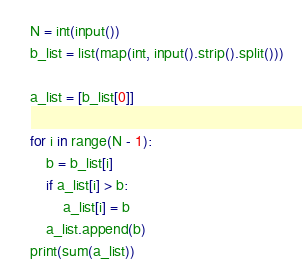Convert code to text. <code><loc_0><loc_0><loc_500><loc_500><_Python_>N = int(input())
b_list = list(map(int, input().strip().split()))

a_list = [b_list[0]]

for i in range(N - 1):
	b = b_list[i]
	if a_list[i] > b:
		a_list[i] = b
	a_list.append(b)
print(sum(a_list))
</code> 